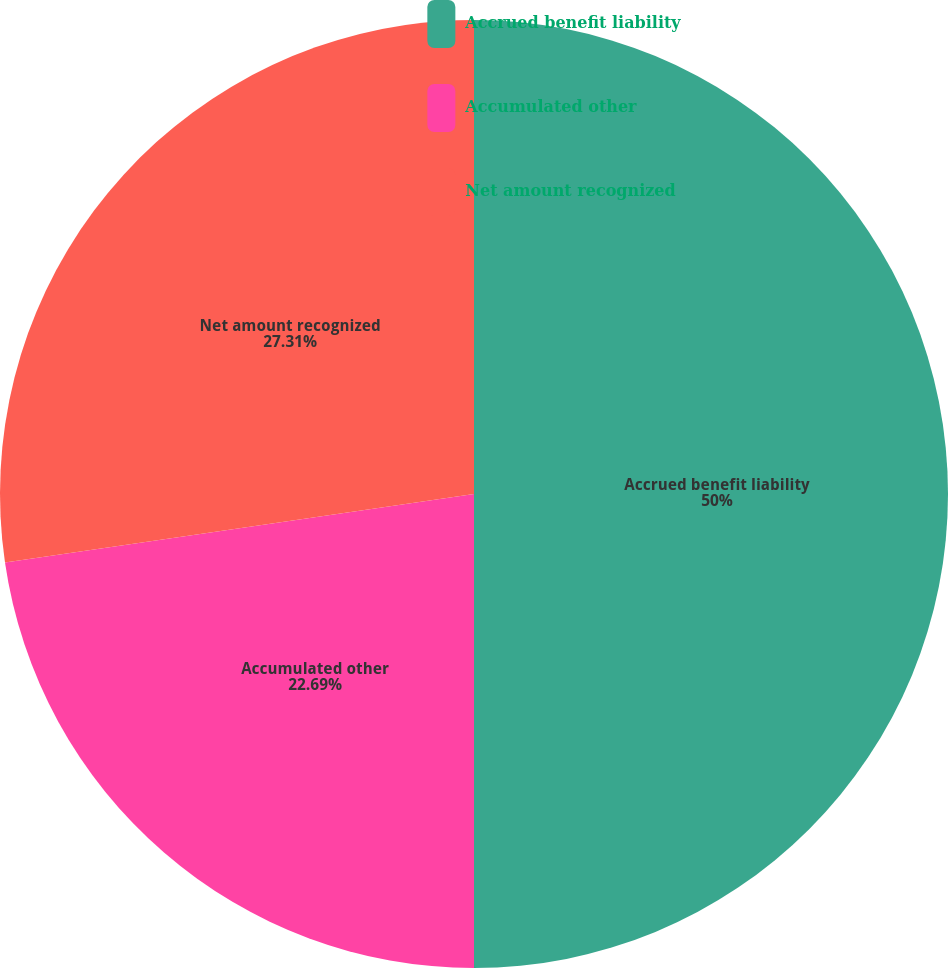Convert chart to OTSL. <chart><loc_0><loc_0><loc_500><loc_500><pie_chart><fcel>Accrued benefit liability<fcel>Accumulated other<fcel>Net amount recognized<nl><fcel>50.0%<fcel>22.69%<fcel>27.31%<nl></chart> 